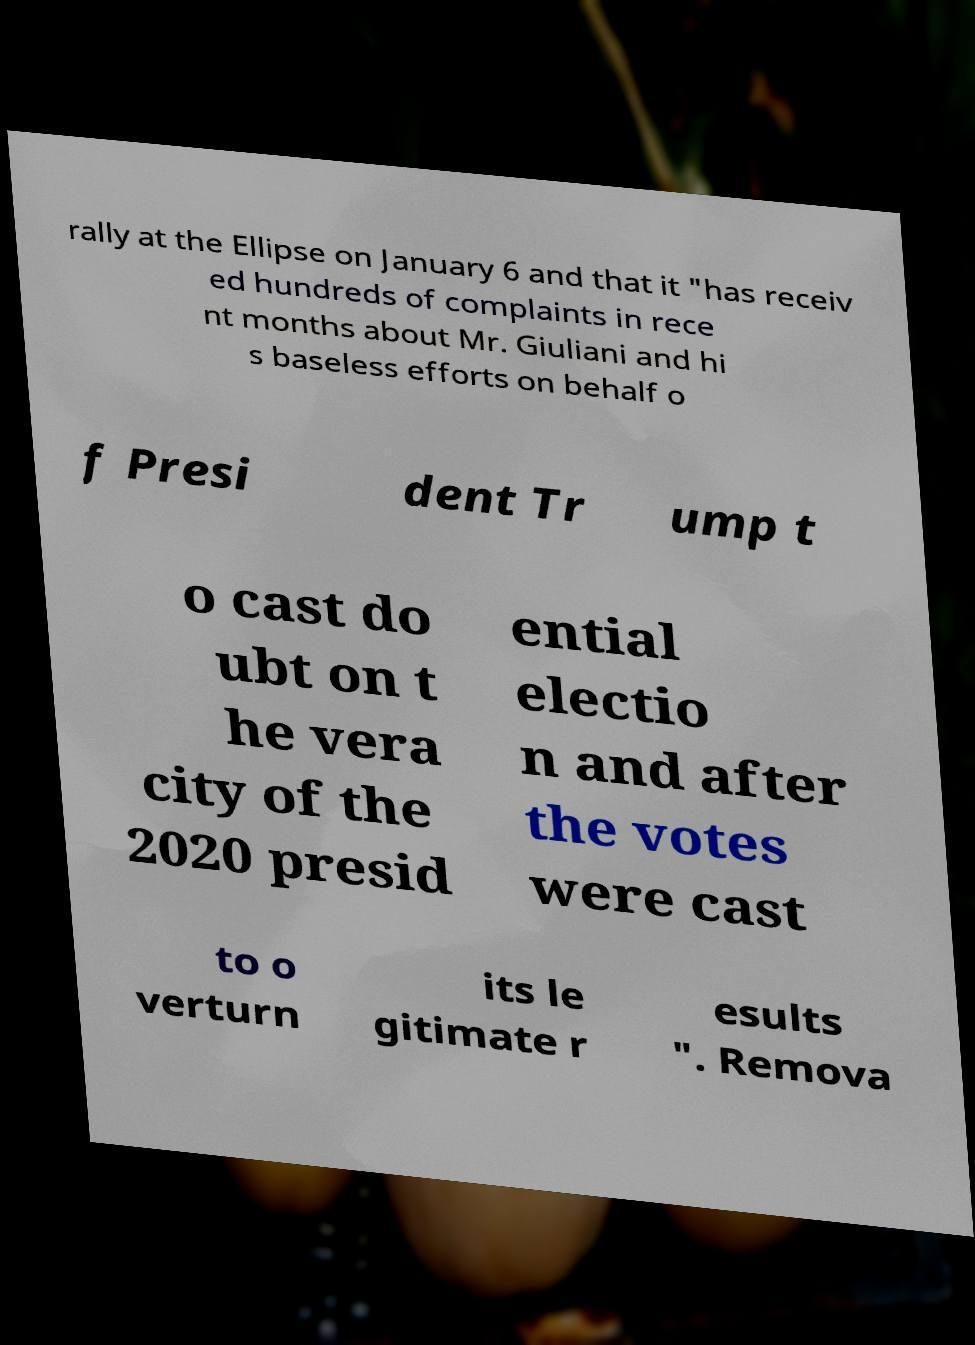Please read and relay the text visible in this image. What does it say? rally at the Ellipse on January 6 and that it "has receiv ed hundreds of complaints in rece nt months about Mr. Giuliani and hi s baseless efforts on behalf o f Presi dent Tr ump t o cast do ubt on t he vera city of the 2020 presid ential electio n and after the votes were cast to o verturn its le gitimate r esults ". Remova 